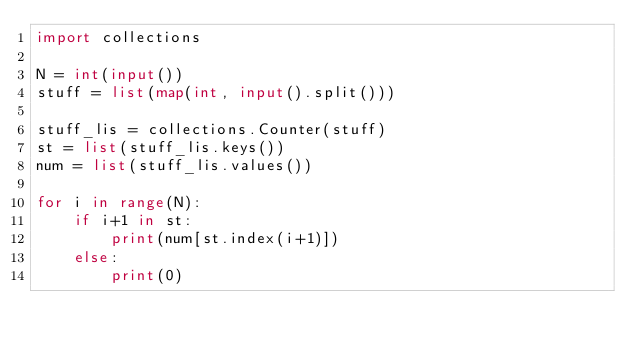<code> <loc_0><loc_0><loc_500><loc_500><_Python_>import collections

N = int(input())
stuff = list(map(int, input().split()))

stuff_lis = collections.Counter(stuff)
st = list(stuff_lis.keys())
num = list(stuff_lis.values())

for i in range(N):
    if i+1 in st:
        print(num[st.index(i+1)])
    else:
        print(0)
</code> 